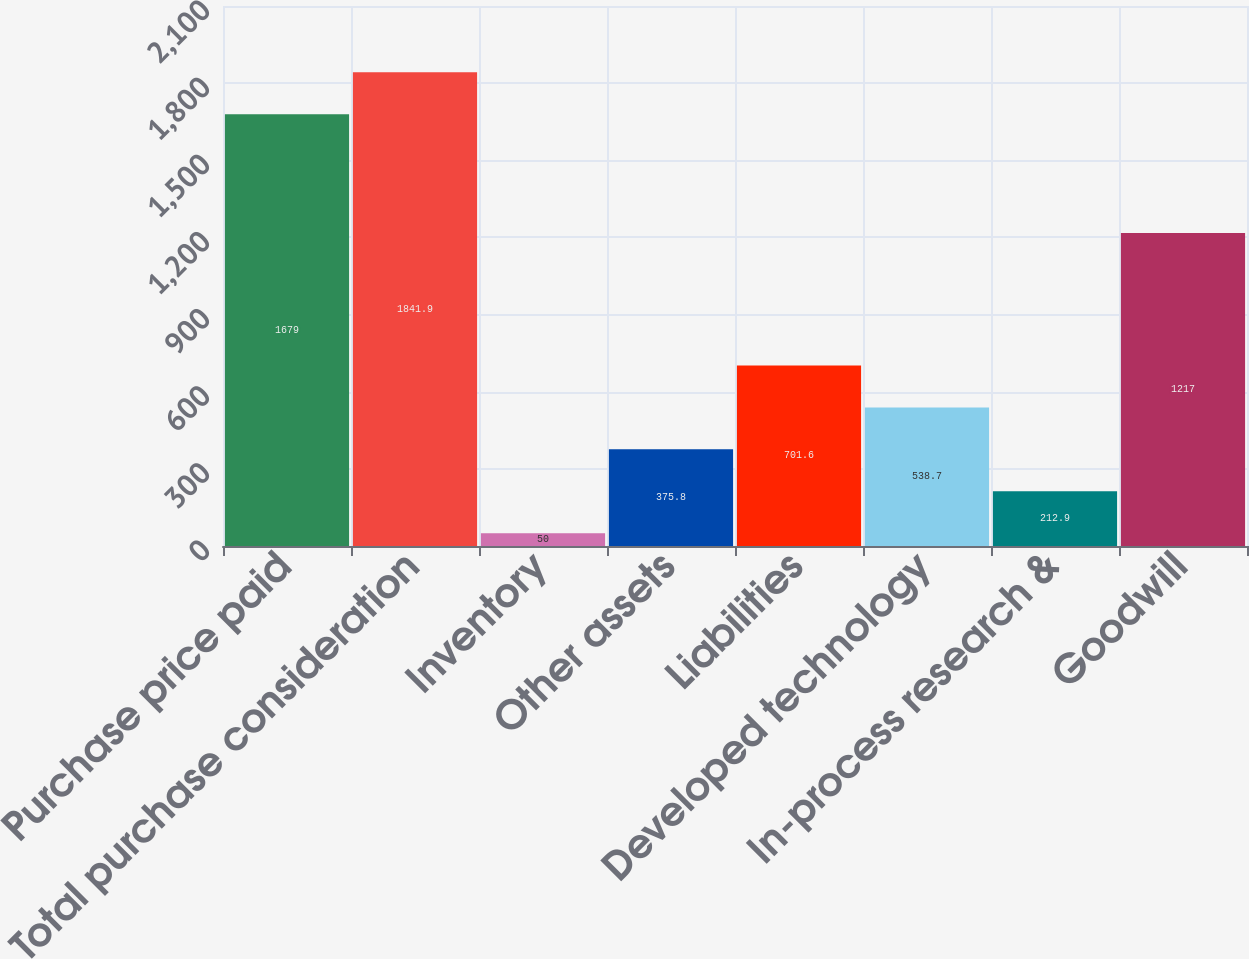Convert chart to OTSL. <chart><loc_0><loc_0><loc_500><loc_500><bar_chart><fcel>Purchase price paid<fcel>Total purchase consideration<fcel>Inventory<fcel>Other assets<fcel>Liabilities<fcel>Developed technology<fcel>In-process research &<fcel>Goodwill<nl><fcel>1679<fcel>1841.9<fcel>50<fcel>375.8<fcel>701.6<fcel>538.7<fcel>212.9<fcel>1217<nl></chart> 